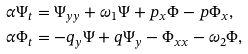<formula> <loc_0><loc_0><loc_500><loc_500>& \alpha \Psi _ { t } = \Psi _ { y y } + \omega _ { 1 } \Psi + p _ { x } \Phi - p \Phi _ { x } , \\ & \alpha \Phi _ { t } = - q _ { y } \Psi + q \Psi _ { y } - \Phi _ { x x } - \omega _ { 2 } \Phi ,</formula> 